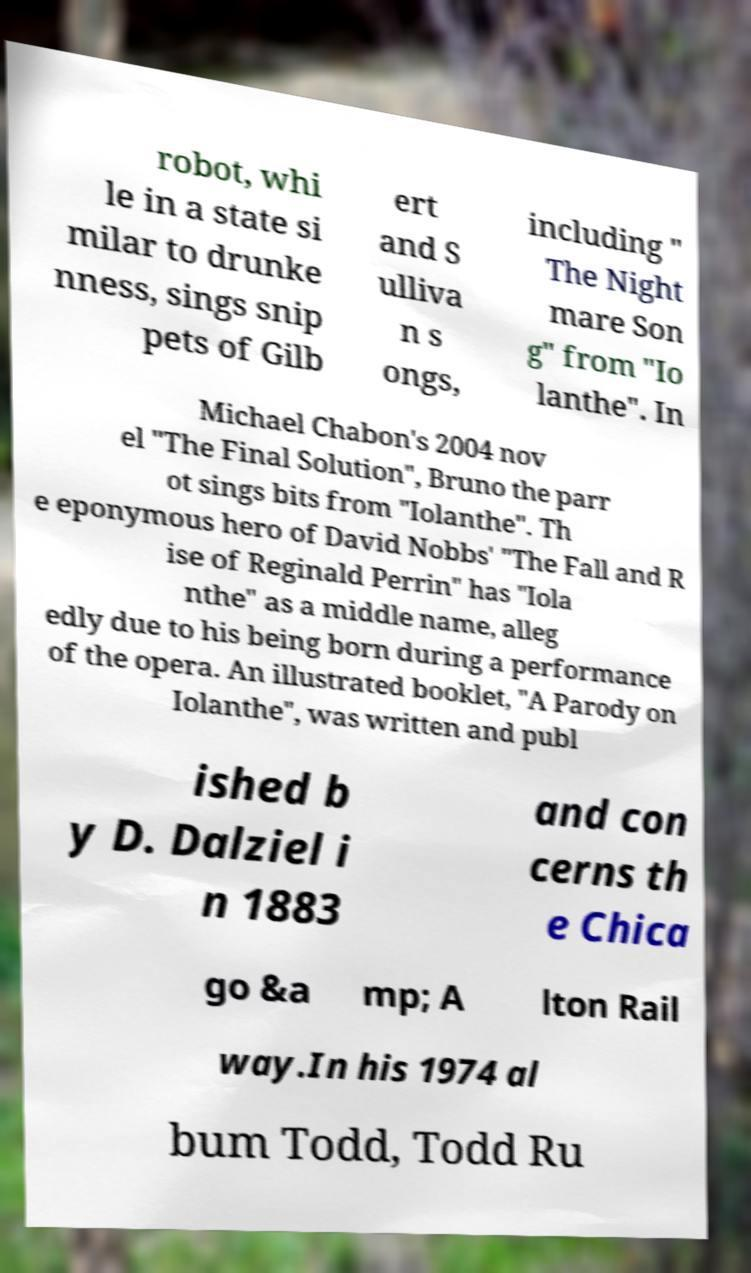For documentation purposes, I need the text within this image transcribed. Could you provide that? robot, whi le in a state si milar to drunke nness, sings snip pets of Gilb ert and S ulliva n s ongs, including " The Night mare Son g" from "Io lanthe". In Michael Chabon's 2004 nov el "The Final Solution", Bruno the parr ot sings bits from "Iolanthe". Th e eponymous hero of David Nobbs' "The Fall and R ise of Reginald Perrin" has "Iola nthe" as a middle name, alleg edly due to his being born during a performance of the opera. An illustrated booklet, "A Parody on Iolanthe", was written and publ ished b y D. Dalziel i n 1883 and con cerns th e Chica go &a mp; A lton Rail way.In his 1974 al bum Todd, Todd Ru 